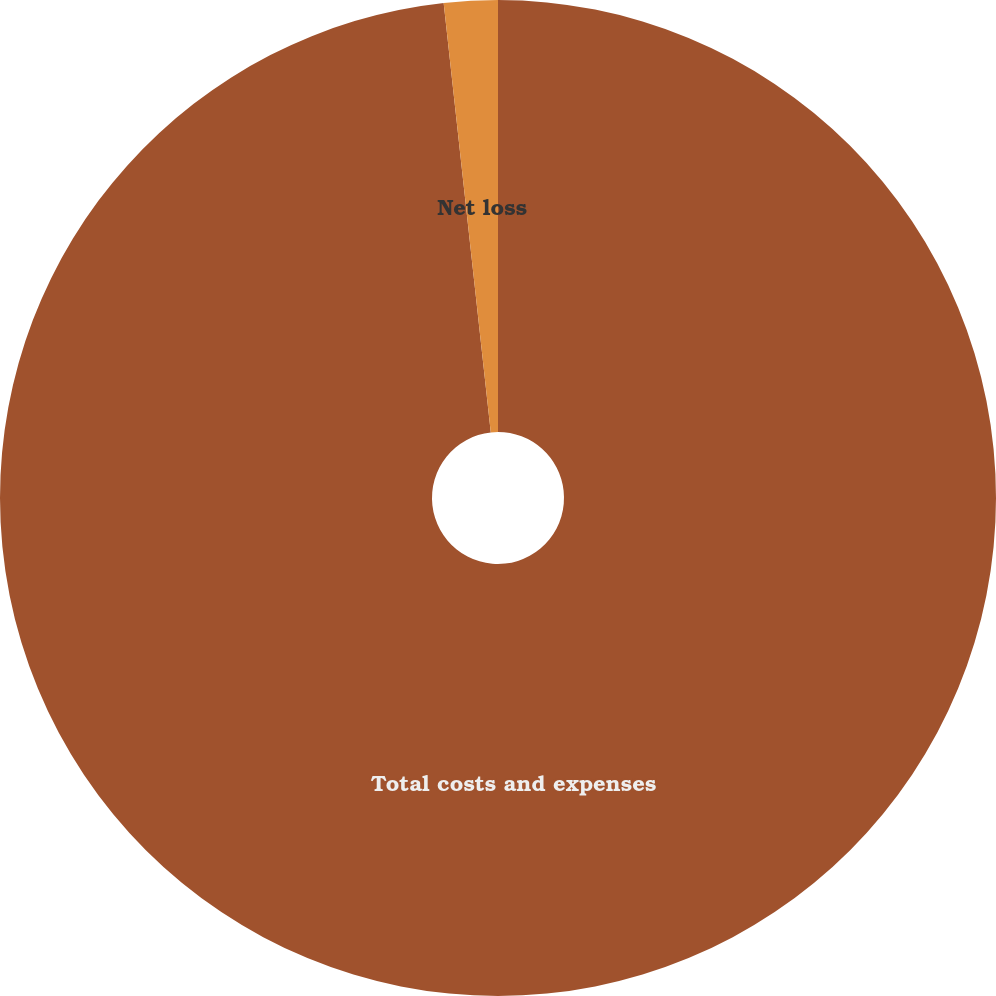Convert chart to OTSL. <chart><loc_0><loc_0><loc_500><loc_500><pie_chart><fcel>Total costs and expenses<fcel>Net loss<nl><fcel>98.26%<fcel>1.74%<nl></chart> 